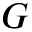<formula> <loc_0><loc_0><loc_500><loc_500>G</formula> 